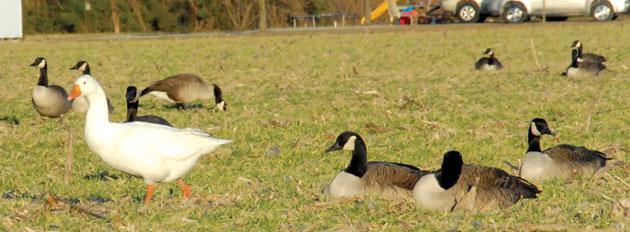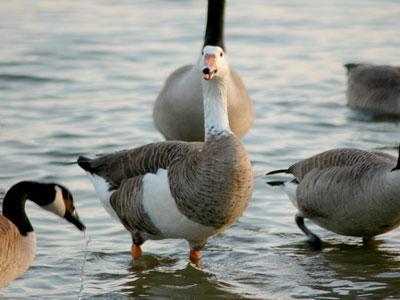The first image is the image on the left, the second image is the image on the right. Examine the images to the left and right. Is the description "There are 6 or more completely white geese." accurate? Answer yes or no. No. The first image is the image on the left, the second image is the image on the right. Given the left and right images, does the statement "There is one white duck in front of any other ducks facing right." hold true? Answer yes or no. No. 